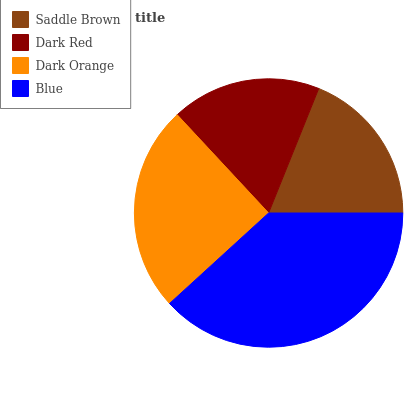Is Dark Red the minimum?
Answer yes or no. Yes. Is Blue the maximum?
Answer yes or no. Yes. Is Dark Orange the minimum?
Answer yes or no. No. Is Dark Orange the maximum?
Answer yes or no. No. Is Dark Orange greater than Dark Red?
Answer yes or no. Yes. Is Dark Red less than Dark Orange?
Answer yes or no. Yes. Is Dark Red greater than Dark Orange?
Answer yes or no. No. Is Dark Orange less than Dark Red?
Answer yes or no. No. Is Dark Orange the high median?
Answer yes or no. Yes. Is Saddle Brown the low median?
Answer yes or no. Yes. Is Saddle Brown the high median?
Answer yes or no. No. Is Blue the low median?
Answer yes or no. No. 